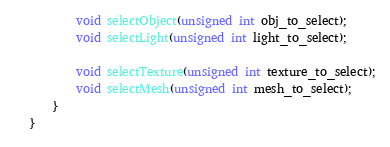Convert code to text. <code><loc_0><loc_0><loc_500><loc_500><_C_>		void selectObject(unsigned int obj_to_select);
		void selectLight(unsigned int light_to_select);

		void selectTexture(unsigned int texture_to_select);
		void selectMesh(unsigned int mesh_to_select);
	}
}</code> 